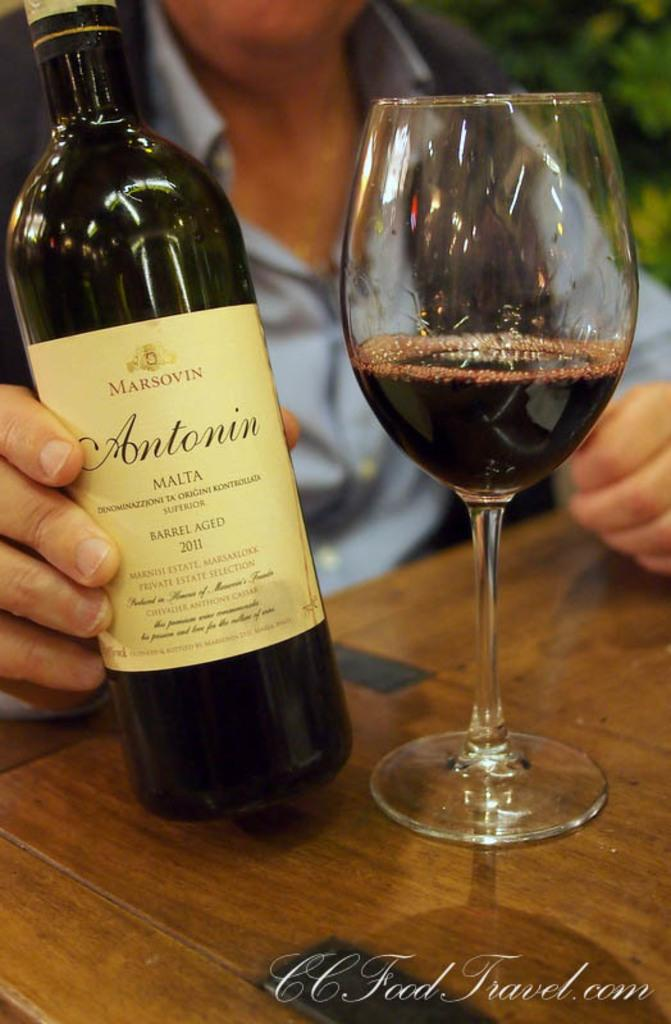<image>
Relay a brief, clear account of the picture shown. Barrel aged bottle of  red wine from Malta and some in glass 